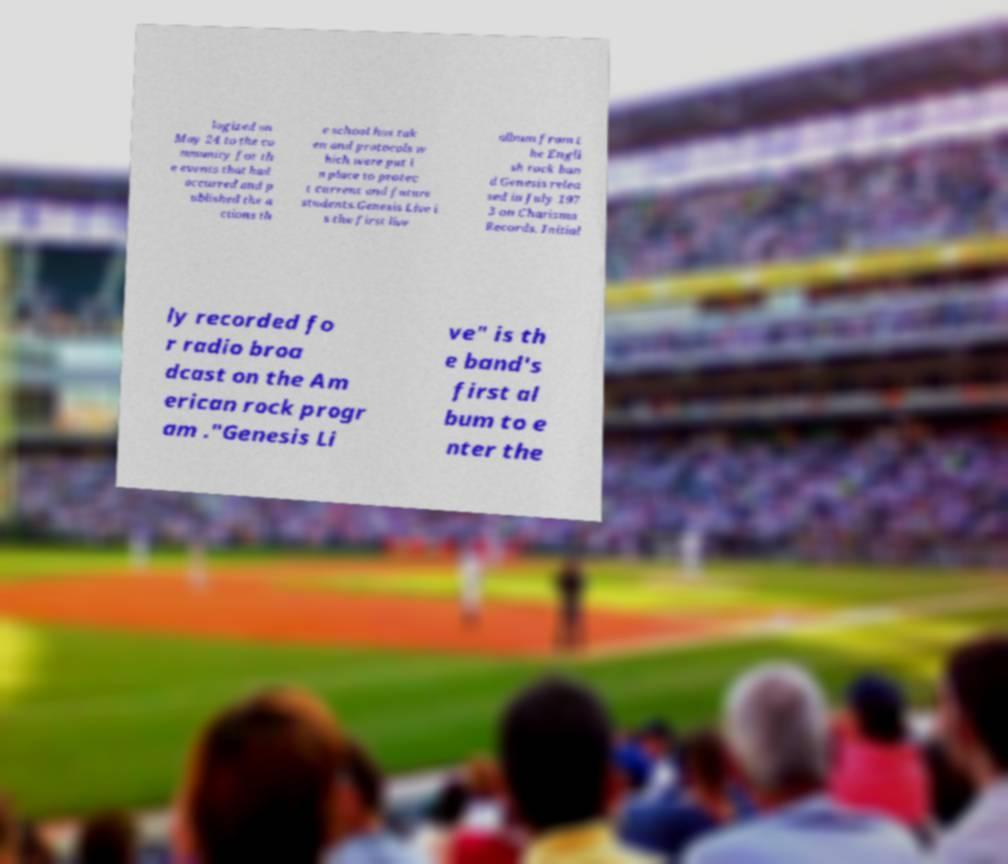For documentation purposes, I need the text within this image transcribed. Could you provide that? logized on May 24 to the co mmunity for th e events that had occurred and p ublished the a ctions th e school has tak en and protocols w hich were put i n place to protec t current and future students.Genesis Live i s the first live album from t he Engli sh rock ban d Genesis relea sed in July 197 3 on Charisma Records. Initial ly recorded fo r radio broa dcast on the Am erican rock progr am ."Genesis Li ve" is th e band's first al bum to e nter the 